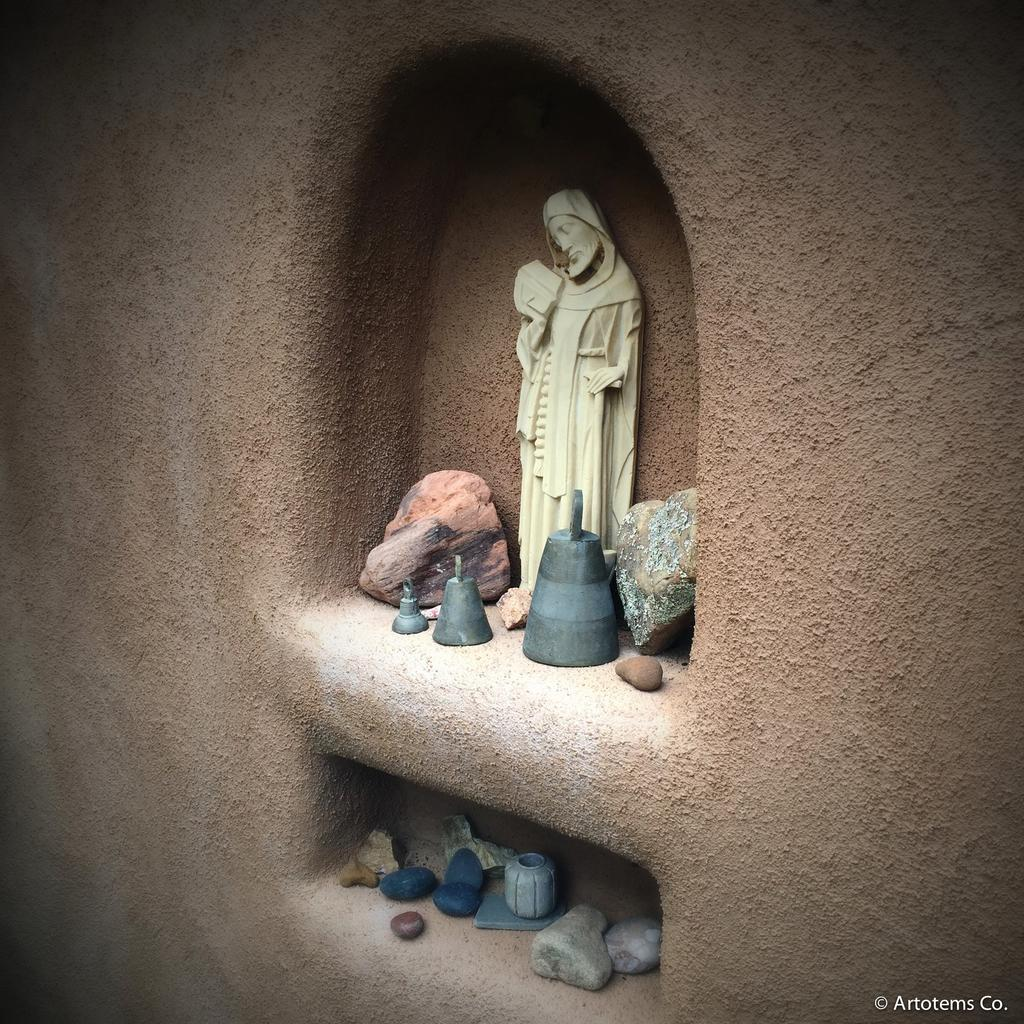What is the main structure visible in the image? There is a wall in the image. What objects can be seen inside the wall? Inside the wall, there are scepters visible. What type of natural elements are present near the wall? Rocks are placed near the wall. How many plants are growing on the scepters in the image? There are no plants visible on the scepters in the image. 